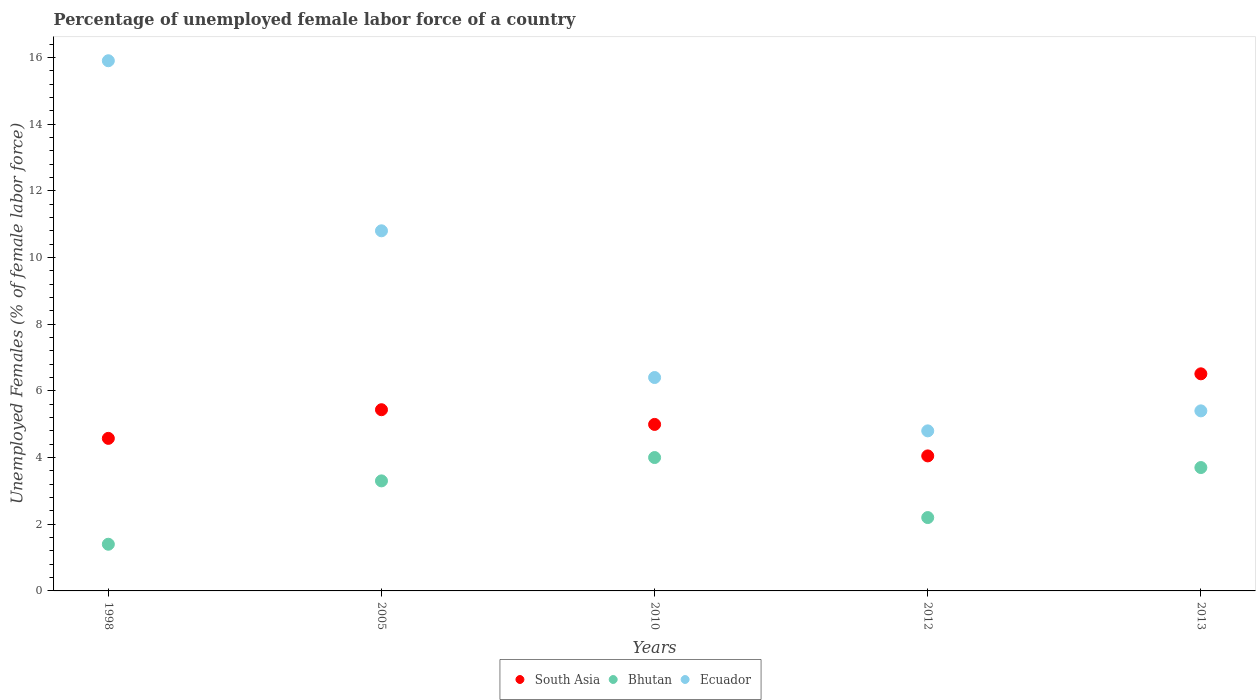How many different coloured dotlines are there?
Offer a terse response. 3. What is the percentage of unemployed female labor force in Ecuador in 2005?
Your answer should be compact. 10.8. Across all years, what is the minimum percentage of unemployed female labor force in South Asia?
Provide a short and direct response. 4.05. In which year was the percentage of unemployed female labor force in Bhutan maximum?
Provide a succinct answer. 2010. What is the total percentage of unemployed female labor force in Ecuador in the graph?
Ensure brevity in your answer.  43.3. What is the difference between the percentage of unemployed female labor force in South Asia in 1998 and that in 2013?
Ensure brevity in your answer.  -1.94. What is the difference between the percentage of unemployed female labor force in Bhutan in 2005 and the percentage of unemployed female labor force in Ecuador in 2012?
Offer a terse response. -1.5. What is the average percentage of unemployed female labor force in Bhutan per year?
Provide a succinct answer. 2.92. In the year 2013, what is the difference between the percentage of unemployed female labor force in Ecuador and percentage of unemployed female labor force in South Asia?
Keep it short and to the point. -1.11. In how many years, is the percentage of unemployed female labor force in Ecuador greater than 8 %?
Provide a succinct answer. 2. What is the ratio of the percentage of unemployed female labor force in Ecuador in 1998 to that in 2010?
Offer a terse response. 2.48. Is the difference between the percentage of unemployed female labor force in Ecuador in 2005 and 2013 greater than the difference between the percentage of unemployed female labor force in South Asia in 2005 and 2013?
Provide a succinct answer. Yes. What is the difference between the highest and the second highest percentage of unemployed female labor force in South Asia?
Provide a succinct answer. 1.08. What is the difference between the highest and the lowest percentage of unemployed female labor force in Bhutan?
Offer a very short reply. 2.6. In how many years, is the percentage of unemployed female labor force in South Asia greater than the average percentage of unemployed female labor force in South Asia taken over all years?
Provide a short and direct response. 2. Is the sum of the percentage of unemployed female labor force in South Asia in 2005 and 2013 greater than the maximum percentage of unemployed female labor force in Ecuador across all years?
Offer a terse response. No. How many dotlines are there?
Provide a short and direct response. 3. Are the values on the major ticks of Y-axis written in scientific E-notation?
Your response must be concise. No. Does the graph contain any zero values?
Ensure brevity in your answer.  No. How are the legend labels stacked?
Your answer should be very brief. Horizontal. What is the title of the graph?
Provide a short and direct response. Percentage of unemployed female labor force of a country. What is the label or title of the Y-axis?
Ensure brevity in your answer.  Unemployed Females (% of female labor force). What is the Unemployed Females (% of female labor force) in South Asia in 1998?
Provide a short and direct response. 4.58. What is the Unemployed Females (% of female labor force) of Bhutan in 1998?
Your answer should be compact. 1.4. What is the Unemployed Females (% of female labor force) of Ecuador in 1998?
Offer a terse response. 15.9. What is the Unemployed Females (% of female labor force) in South Asia in 2005?
Provide a short and direct response. 5.43. What is the Unemployed Females (% of female labor force) in Bhutan in 2005?
Keep it short and to the point. 3.3. What is the Unemployed Females (% of female labor force) in Ecuador in 2005?
Give a very brief answer. 10.8. What is the Unemployed Females (% of female labor force) of South Asia in 2010?
Offer a very short reply. 4.99. What is the Unemployed Females (% of female labor force) of Bhutan in 2010?
Keep it short and to the point. 4. What is the Unemployed Females (% of female labor force) of Ecuador in 2010?
Your answer should be compact. 6.4. What is the Unemployed Females (% of female labor force) in South Asia in 2012?
Ensure brevity in your answer.  4.05. What is the Unemployed Females (% of female labor force) of Bhutan in 2012?
Make the answer very short. 2.2. What is the Unemployed Females (% of female labor force) in Ecuador in 2012?
Make the answer very short. 4.8. What is the Unemployed Females (% of female labor force) in South Asia in 2013?
Ensure brevity in your answer.  6.51. What is the Unemployed Females (% of female labor force) in Bhutan in 2013?
Give a very brief answer. 3.7. What is the Unemployed Females (% of female labor force) of Ecuador in 2013?
Offer a very short reply. 5.4. Across all years, what is the maximum Unemployed Females (% of female labor force) of South Asia?
Keep it short and to the point. 6.51. Across all years, what is the maximum Unemployed Females (% of female labor force) of Ecuador?
Keep it short and to the point. 15.9. Across all years, what is the minimum Unemployed Females (% of female labor force) in South Asia?
Provide a short and direct response. 4.05. Across all years, what is the minimum Unemployed Females (% of female labor force) of Bhutan?
Make the answer very short. 1.4. Across all years, what is the minimum Unemployed Females (% of female labor force) in Ecuador?
Your answer should be compact. 4.8. What is the total Unemployed Females (% of female labor force) of South Asia in the graph?
Give a very brief answer. 25.56. What is the total Unemployed Females (% of female labor force) of Bhutan in the graph?
Offer a very short reply. 14.6. What is the total Unemployed Females (% of female labor force) of Ecuador in the graph?
Provide a succinct answer. 43.3. What is the difference between the Unemployed Females (% of female labor force) in South Asia in 1998 and that in 2005?
Offer a terse response. -0.86. What is the difference between the Unemployed Females (% of female labor force) in Ecuador in 1998 and that in 2005?
Offer a very short reply. 5.1. What is the difference between the Unemployed Females (% of female labor force) of South Asia in 1998 and that in 2010?
Provide a short and direct response. -0.42. What is the difference between the Unemployed Females (% of female labor force) of Bhutan in 1998 and that in 2010?
Make the answer very short. -2.6. What is the difference between the Unemployed Females (% of female labor force) of Ecuador in 1998 and that in 2010?
Give a very brief answer. 9.5. What is the difference between the Unemployed Females (% of female labor force) of South Asia in 1998 and that in 2012?
Keep it short and to the point. 0.53. What is the difference between the Unemployed Females (% of female labor force) in Bhutan in 1998 and that in 2012?
Ensure brevity in your answer.  -0.8. What is the difference between the Unemployed Females (% of female labor force) of South Asia in 1998 and that in 2013?
Ensure brevity in your answer.  -1.94. What is the difference between the Unemployed Females (% of female labor force) in South Asia in 2005 and that in 2010?
Provide a succinct answer. 0.44. What is the difference between the Unemployed Females (% of female labor force) of Bhutan in 2005 and that in 2010?
Your response must be concise. -0.7. What is the difference between the Unemployed Females (% of female labor force) of South Asia in 2005 and that in 2012?
Your response must be concise. 1.39. What is the difference between the Unemployed Females (% of female labor force) in South Asia in 2005 and that in 2013?
Give a very brief answer. -1.08. What is the difference between the Unemployed Females (% of female labor force) in Ecuador in 2005 and that in 2013?
Provide a short and direct response. 5.4. What is the difference between the Unemployed Females (% of female labor force) in South Asia in 2010 and that in 2012?
Offer a very short reply. 0.94. What is the difference between the Unemployed Females (% of female labor force) of Bhutan in 2010 and that in 2012?
Offer a terse response. 1.8. What is the difference between the Unemployed Females (% of female labor force) of South Asia in 2010 and that in 2013?
Provide a succinct answer. -1.52. What is the difference between the Unemployed Females (% of female labor force) in South Asia in 2012 and that in 2013?
Give a very brief answer. -2.46. What is the difference between the Unemployed Females (% of female labor force) in Bhutan in 2012 and that in 2013?
Keep it short and to the point. -1.5. What is the difference between the Unemployed Females (% of female labor force) of Ecuador in 2012 and that in 2013?
Provide a short and direct response. -0.6. What is the difference between the Unemployed Females (% of female labor force) in South Asia in 1998 and the Unemployed Females (% of female labor force) in Bhutan in 2005?
Your answer should be compact. 1.28. What is the difference between the Unemployed Females (% of female labor force) of South Asia in 1998 and the Unemployed Females (% of female labor force) of Ecuador in 2005?
Offer a very short reply. -6.22. What is the difference between the Unemployed Females (% of female labor force) in Bhutan in 1998 and the Unemployed Females (% of female labor force) in Ecuador in 2005?
Give a very brief answer. -9.4. What is the difference between the Unemployed Females (% of female labor force) of South Asia in 1998 and the Unemployed Females (% of female labor force) of Bhutan in 2010?
Your answer should be compact. 0.58. What is the difference between the Unemployed Females (% of female labor force) of South Asia in 1998 and the Unemployed Females (% of female labor force) of Ecuador in 2010?
Give a very brief answer. -1.82. What is the difference between the Unemployed Females (% of female labor force) of South Asia in 1998 and the Unemployed Females (% of female labor force) of Bhutan in 2012?
Offer a very short reply. 2.38. What is the difference between the Unemployed Females (% of female labor force) in South Asia in 1998 and the Unemployed Females (% of female labor force) in Ecuador in 2012?
Your answer should be compact. -0.22. What is the difference between the Unemployed Females (% of female labor force) in Bhutan in 1998 and the Unemployed Females (% of female labor force) in Ecuador in 2012?
Your answer should be compact. -3.4. What is the difference between the Unemployed Females (% of female labor force) of South Asia in 1998 and the Unemployed Females (% of female labor force) of Bhutan in 2013?
Give a very brief answer. 0.88. What is the difference between the Unemployed Females (% of female labor force) in South Asia in 1998 and the Unemployed Females (% of female labor force) in Ecuador in 2013?
Your response must be concise. -0.82. What is the difference between the Unemployed Females (% of female labor force) of South Asia in 2005 and the Unemployed Females (% of female labor force) of Bhutan in 2010?
Offer a terse response. 1.43. What is the difference between the Unemployed Females (% of female labor force) of South Asia in 2005 and the Unemployed Females (% of female labor force) of Ecuador in 2010?
Give a very brief answer. -0.97. What is the difference between the Unemployed Females (% of female labor force) in South Asia in 2005 and the Unemployed Females (% of female labor force) in Bhutan in 2012?
Give a very brief answer. 3.23. What is the difference between the Unemployed Females (% of female labor force) in South Asia in 2005 and the Unemployed Females (% of female labor force) in Ecuador in 2012?
Your answer should be very brief. 0.63. What is the difference between the Unemployed Females (% of female labor force) of South Asia in 2005 and the Unemployed Females (% of female labor force) of Bhutan in 2013?
Offer a very short reply. 1.73. What is the difference between the Unemployed Females (% of female labor force) in South Asia in 2005 and the Unemployed Females (% of female labor force) in Ecuador in 2013?
Provide a succinct answer. 0.03. What is the difference between the Unemployed Females (% of female labor force) in Bhutan in 2005 and the Unemployed Females (% of female labor force) in Ecuador in 2013?
Offer a very short reply. -2.1. What is the difference between the Unemployed Females (% of female labor force) of South Asia in 2010 and the Unemployed Females (% of female labor force) of Bhutan in 2012?
Make the answer very short. 2.79. What is the difference between the Unemployed Females (% of female labor force) of South Asia in 2010 and the Unemployed Females (% of female labor force) of Ecuador in 2012?
Ensure brevity in your answer.  0.19. What is the difference between the Unemployed Females (% of female labor force) in South Asia in 2010 and the Unemployed Females (% of female labor force) in Bhutan in 2013?
Provide a succinct answer. 1.29. What is the difference between the Unemployed Females (% of female labor force) in South Asia in 2010 and the Unemployed Females (% of female labor force) in Ecuador in 2013?
Provide a succinct answer. -0.41. What is the difference between the Unemployed Females (% of female labor force) of Bhutan in 2010 and the Unemployed Females (% of female labor force) of Ecuador in 2013?
Your response must be concise. -1.4. What is the difference between the Unemployed Females (% of female labor force) in South Asia in 2012 and the Unemployed Females (% of female labor force) in Bhutan in 2013?
Offer a terse response. 0.35. What is the difference between the Unemployed Females (% of female labor force) of South Asia in 2012 and the Unemployed Females (% of female labor force) of Ecuador in 2013?
Offer a very short reply. -1.35. What is the average Unemployed Females (% of female labor force) in South Asia per year?
Your response must be concise. 5.11. What is the average Unemployed Females (% of female labor force) of Bhutan per year?
Your response must be concise. 2.92. What is the average Unemployed Females (% of female labor force) of Ecuador per year?
Your answer should be compact. 8.66. In the year 1998, what is the difference between the Unemployed Females (% of female labor force) of South Asia and Unemployed Females (% of female labor force) of Bhutan?
Offer a terse response. 3.18. In the year 1998, what is the difference between the Unemployed Females (% of female labor force) of South Asia and Unemployed Females (% of female labor force) of Ecuador?
Offer a terse response. -11.32. In the year 2005, what is the difference between the Unemployed Females (% of female labor force) of South Asia and Unemployed Females (% of female labor force) of Bhutan?
Provide a succinct answer. 2.13. In the year 2005, what is the difference between the Unemployed Females (% of female labor force) in South Asia and Unemployed Females (% of female labor force) in Ecuador?
Provide a succinct answer. -5.37. In the year 2010, what is the difference between the Unemployed Females (% of female labor force) in South Asia and Unemployed Females (% of female labor force) in Ecuador?
Keep it short and to the point. -1.41. In the year 2010, what is the difference between the Unemployed Females (% of female labor force) of Bhutan and Unemployed Females (% of female labor force) of Ecuador?
Offer a terse response. -2.4. In the year 2012, what is the difference between the Unemployed Females (% of female labor force) of South Asia and Unemployed Females (% of female labor force) of Bhutan?
Your response must be concise. 1.85. In the year 2012, what is the difference between the Unemployed Females (% of female labor force) of South Asia and Unemployed Females (% of female labor force) of Ecuador?
Keep it short and to the point. -0.75. In the year 2013, what is the difference between the Unemployed Females (% of female labor force) in South Asia and Unemployed Females (% of female labor force) in Bhutan?
Your answer should be very brief. 2.81. In the year 2013, what is the difference between the Unemployed Females (% of female labor force) of South Asia and Unemployed Females (% of female labor force) of Ecuador?
Give a very brief answer. 1.11. What is the ratio of the Unemployed Females (% of female labor force) of South Asia in 1998 to that in 2005?
Provide a succinct answer. 0.84. What is the ratio of the Unemployed Females (% of female labor force) in Bhutan in 1998 to that in 2005?
Your answer should be very brief. 0.42. What is the ratio of the Unemployed Females (% of female labor force) in Ecuador in 1998 to that in 2005?
Your answer should be very brief. 1.47. What is the ratio of the Unemployed Females (% of female labor force) in South Asia in 1998 to that in 2010?
Keep it short and to the point. 0.92. What is the ratio of the Unemployed Females (% of female labor force) in Bhutan in 1998 to that in 2010?
Offer a very short reply. 0.35. What is the ratio of the Unemployed Females (% of female labor force) in Ecuador in 1998 to that in 2010?
Offer a very short reply. 2.48. What is the ratio of the Unemployed Females (% of female labor force) of South Asia in 1998 to that in 2012?
Your response must be concise. 1.13. What is the ratio of the Unemployed Females (% of female labor force) of Bhutan in 1998 to that in 2012?
Ensure brevity in your answer.  0.64. What is the ratio of the Unemployed Females (% of female labor force) of Ecuador in 1998 to that in 2012?
Provide a succinct answer. 3.31. What is the ratio of the Unemployed Females (% of female labor force) of South Asia in 1998 to that in 2013?
Provide a short and direct response. 0.7. What is the ratio of the Unemployed Females (% of female labor force) in Bhutan in 1998 to that in 2013?
Offer a very short reply. 0.38. What is the ratio of the Unemployed Females (% of female labor force) of Ecuador in 1998 to that in 2013?
Make the answer very short. 2.94. What is the ratio of the Unemployed Females (% of female labor force) of South Asia in 2005 to that in 2010?
Your answer should be very brief. 1.09. What is the ratio of the Unemployed Females (% of female labor force) of Bhutan in 2005 to that in 2010?
Offer a very short reply. 0.82. What is the ratio of the Unemployed Females (% of female labor force) in Ecuador in 2005 to that in 2010?
Provide a short and direct response. 1.69. What is the ratio of the Unemployed Females (% of female labor force) of South Asia in 2005 to that in 2012?
Provide a short and direct response. 1.34. What is the ratio of the Unemployed Females (% of female labor force) of Bhutan in 2005 to that in 2012?
Offer a terse response. 1.5. What is the ratio of the Unemployed Females (% of female labor force) in Ecuador in 2005 to that in 2012?
Provide a succinct answer. 2.25. What is the ratio of the Unemployed Females (% of female labor force) in South Asia in 2005 to that in 2013?
Your answer should be compact. 0.83. What is the ratio of the Unemployed Females (% of female labor force) of Bhutan in 2005 to that in 2013?
Your answer should be very brief. 0.89. What is the ratio of the Unemployed Females (% of female labor force) in South Asia in 2010 to that in 2012?
Your answer should be compact. 1.23. What is the ratio of the Unemployed Females (% of female labor force) of Bhutan in 2010 to that in 2012?
Your answer should be compact. 1.82. What is the ratio of the Unemployed Females (% of female labor force) in Ecuador in 2010 to that in 2012?
Give a very brief answer. 1.33. What is the ratio of the Unemployed Females (% of female labor force) of South Asia in 2010 to that in 2013?
Give a very brief answer. 0.77. What is the ratio of the Unemployed Females (% of female labor force) of Bhutan in 2010 to that in 2013?
Provide a short and direct response. 1.08. What is the ratio of the Unemployed Females (% of female labor force) of Ecuador in 2010 to that in 2013?
Your answer should be compact. 1.19. What is the ratio of the Unemployed Females (% of female labor force) of South Asia in 2012 to that in 2013?
Offer a terse response. 0.62. What is the ratio of the Unemployed Females (% of female labor force) in Bhutan in 2012 to that in 2013?
Make the answer very short. 0.59. What is the ratio of the Unemployed Females (% of female labor force) in Ecuador in 2012 to that in 2013?
Make the answer very short. 0.89. What is the difference between the highest and the second highest Unemployed Females (% of female labor force) in South Asia?
Provide a succinct answer. 1.08. What is the difference between the highest and the lowest Unemployed Females (% of female labor force) in South Asia?
Give a very brief answer. 2.46. 